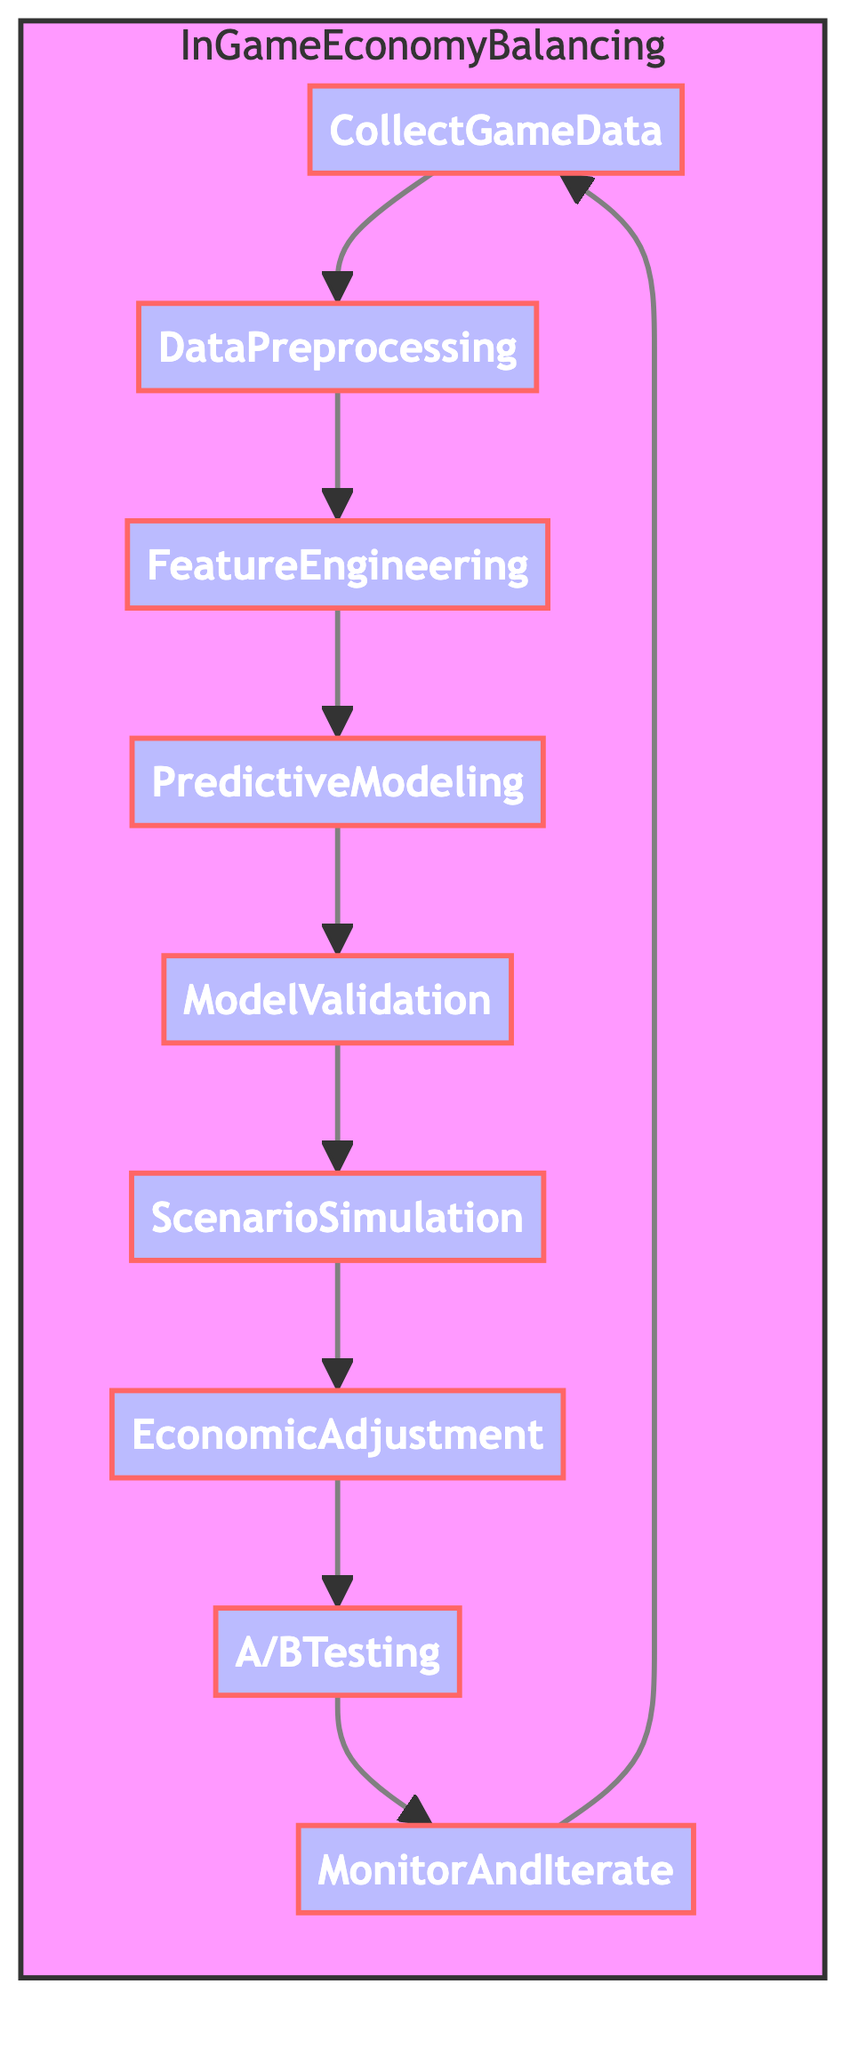What is the first step in the InGameEconomyBalancing process? The first step in the process as shown in the diagram is "CollectGameData," which is indicated as the starting point from which all other steps flow.
Answer: CollectGameData How many total nodes are there in the diagram? The diagram consists of nine nodes representing each step in the InGameEconomyBalancing function, confirming that there are nine distinct actions or processes within the flow.
Answer: Nine What follows after DataPreprocessing? According to the flowchart, the step that follows "DataPreprocessing" is "FeatureEngineering," as depicted in the sequence of process flow.
Answer: FeatureEngineering Which step comes before A/B Testing? In the diagram, "EconomicAdjustment" is the step that precedes "A/BTesting," demonstrating the flow of adjustments leading to the testing phase.
Answer: EconomicAdjustment What is the last step in the InGameEconomyBalancing process before looping back? The last step shown in the diagram before returning to the start is "MonitorAndIterate," indicating continuous monitoring as the final step in the cycle.
Answer: MonitorAndIterate How many edges are there connecting the nodes? The flowchart features eight edges that connect the nodes, indicating the directed relationships between each of the outlined processes within the InGameEconomyBalancing function.
Answer: Eight Which two steps are directly connected to Feature Engineering? "DataPreprocessing" is directly connected before "FeatureEngineering," and "PredictiveModeling" follows immediately after, showcasing the input and output relationship of this step.
Answer: DataPreprocessing and PredictiveModeling Is Scenario Simulation a prerequisite for Economic Adjustment? Yes, the flowchart illustrates that "ScenarioSimulation" must be completed before "EconomicAdjustment" can occur, demonstrating a clear dependency between these two processes.
Answer: Yes What is the last node in the cycle of the diagram? The last node before the cycle back to "CollectGameData" is "MonitorAndIterate," marking the end of the sequence before it resets to the beginning.
Answer: MonitorAndIterate 